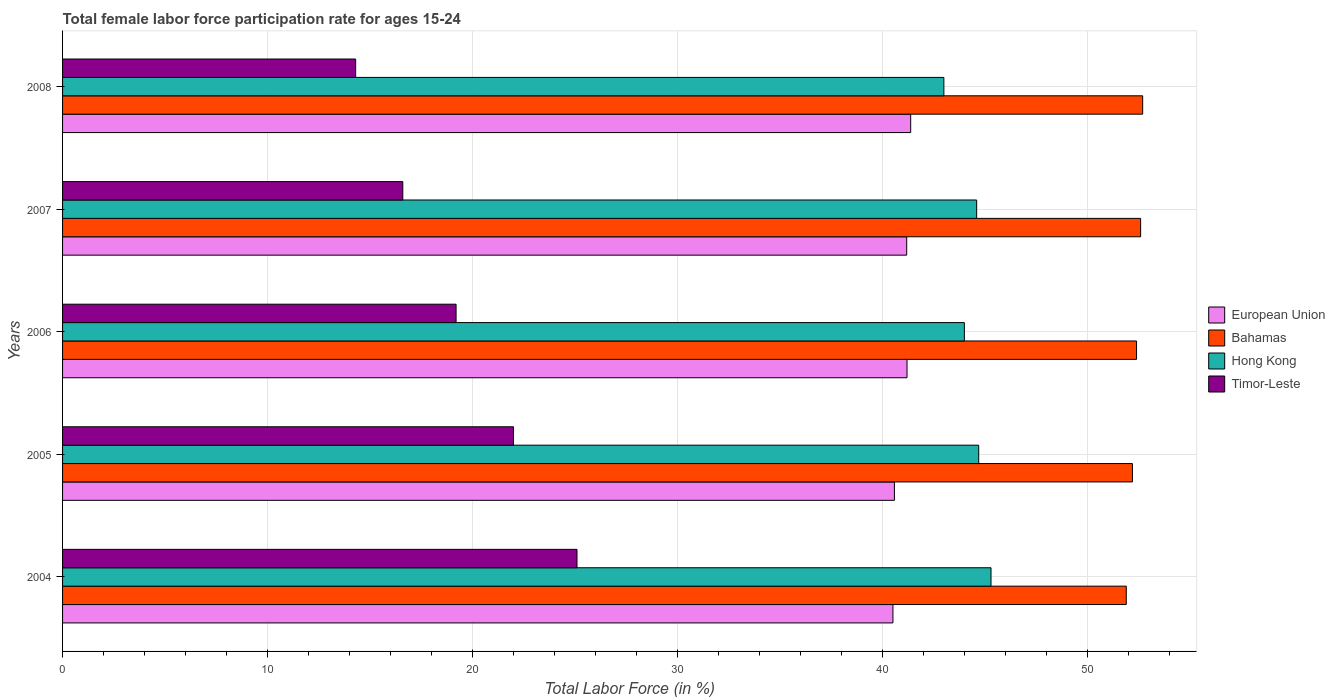How many groups of bars are there?
Give a very brief answer. 5. Are the number of bars per tick equal to the number of legend labels?
Offer a terse response. Yes. Are the number of bars on each tick of the Y-axis equal?
Ensure brevity in your answer.  Yes. How many bars are there on the 3rd tick from the bottom?
Give a very brief answer. 4. In how many cases, is the number of bars for a given year not equal to the number of legend labels?
Your response must be concise. 0. Across all years, what is the maximum female labor force participation rate in European Union?
Offer a terse response. 41.38. Across all years, what is the minimum female labor force participation rate in Hong Kong?
Keep it short and to the point. 43. What is the total female labor force participation rate in Timor-Leste in the graph?
Make the answer very short. 97.2. What is the difference between the female labor force participation rate in European Union in 2005 and the female labor force participation rate in Timor-Leste in 2007?
Offer a terse response. 23.99. What is the average female labor force participation rate in Timor-Leste per year?
Your answer should be compact. 19.44. In the year 2006, what is the difference between the female labor force participation rate in Hong Kong and female labor force participation rate in Bahamas?
Offer a terse response. -8.4. What is the ratio of the female labor force participation rate in Hong Kong in 2006 to that in 2008?
Provide a succinct answer. 1.02. Is the difference between the female labor force participation rate in Hong Kong in 2005 and 2006 greater than the difference between the female labor force participation rate in Bahamas in 2005 and 2006?
Offer a very short reply. Yes. What is the difference between the highest and the second highest female labor force participation rate in Hong Kong?
Offer a terse response. 0.6. What is the difference between the highest and the lowest female labor force participation rate in European Union?
Your answer should be very brief. 0.87. In how many years, is the female labor force participation rate in Hong Kong greater than the average female labor force participation rate in Hong Kong taken over all years?
Your response must be concise. 3. Is it the case that in every year, the sum of the female labor force participation rate in Hong Kong and female labor force participation rate in Timor-Leste is greater than the sum of female labor force participation rate in European Union and female labor force participation rate in Bahamas?
Your answer should be very brief. No. What does the 4th bar from the top in 2004 represents?
Ensure brevity in your answer.  European Union. What does the 3rd bar from the bottom in 2004 represents?
Your answer should be compact. Hong Kong. How many bars are there?
Make the answer very short. 20. How many years are there in the graph?
Your response must be concise. 5. Are the values on the major ticks of X-axis written in scientific E-notation?
Offer a very short reply. No. Does the graph contain any zero values?
Keep it short and to the point. No. How many legend labels are there?
Provide a short and direct response. 4. What is the title of the graph?
Keep it short and to the point. Total female labor force participation rate for ages 15-24. Does "Bermuda" appear as one of the legend labels in the graph?
Provide a short and direct response. No. What is the label or title of the Y-axis?
Provide a short and direct response. Years. What is the Total Labor Force (in %) in European Union in 2004?
Your answer should be compact. 40.51. What is the Total Labor Force (in %) of Bahamas in 2004?
Your answer should be very brief. 51.9. What is the Total Labor Force (in %) in Hong Kong in 2004?
Your answer should be compact. 45.3. What is the Total Labor Force (in %) in Timor-Leste in 2004?
Make the answer very short. 25.1. What is the Total Labor Force (in %) of European Union in 2005?
Offer a very short reply. 40.59. What is the Total Labor Force (in %) of Bahamas in 2005?
Your answer should be very brief. 52.2. What is the Total Labor Force (in %) in Hong Kong in 2005?
Your response must be concise. 44.7. What is the Total Labor Force (in %) in European Union in 2006?
Ensure brevity in your answer.  41.2. What is the Total Labor Force (in %) of Bahamas in 2006?
Offer a very short reply. 52.4. What is the Total Labor Force (in %) in Hong Kong in 2006?
Your answer should be very brief. 44. What is the Total Labor Force (in %) in Timor-Leste in 2006?
Offer a terse response. 19.2. What is the Total Labor Force (in %) in European Union in 2007?
Your response must be concise. 41.19. What is the Total Labor Force (in %) of Bahamas in 2007?
Make the answer very short. 52.6. What is the Total Labor Force (in %) in Hong Kong in 2007?
Provide a short and direct response. 44.6. What is the Total Labor Force (in %) of Timor-Leste in 2007?
Give a very brief answer. 16.6. What is the Total Labor Force (in %) in European Union in 2008?
Give a very brief answer. 41.38. What is the Total Labor Force (in %) of Bahamas in 2008?
Offer a terse response. 52.7. What is the Total Labor Force (in %) in Timor-Leste in 2008?
Give a very brief answer. 14.3. Across all years, what is the maximum Total Labor Force (in %) of European Union?
Provide a succinct answer. 41.38. Across all years, what is the maximum Total Labor Force (in %) in Bahamas?
Make the answer very short. 52.7. Across all years, what is the maximum Total Labor Force (in %) in Hong Kong?
Provide a short and direct response. 45.3. Across all years, what is the maximum Total Labor Force (in %) of Timor-Leste?
Your answer should be very brief. 25.1. Across all years, what is the minimum Total Labor Force (in %) in European Union?
Give a very brief answer. 40.51. Across all years, what is the minimum Total Labor Force (in %) in Bahamas?
Ensure brevity in your answer.  51.9. Across all years, what is the minimum Total Labor Force (in %) of Hong Kong?
Keep it short and to the point. 43. Across all years, what is the minimum Total Labor Force (in %) in Timor-Leste?
Your response must be concise. 14.3. What is the total Total Labor Force (in %) in European Union in the graph?
Keep it short and to the point. 204.87. What is the total Total Labor Force (in %) in Bahamas in the graph?
Provide a succinct answer. 261.8. What is the total Total Labor Force (in %) of Hong Kong in the graph?
Your answer should be compact. 221.6. What is the total Total Labor Force (in %) in Timor-Leste in the graph?
Your response must be concise. 97.2. What is the difference between the Total Labor Force (in %) of European Union in 2004 and that in 2005?
Keep it short and to the point. -0.07. What is the difference between the Total Labor Force (in %) of Bahamas in 2004 and that in 2005?
Provide a succinct answer. -0.3. What is the difference between the Total Labor Force (in %) of Timor-Leste in 2004 and that in 2005?
Your answer should be very brief. 3.1. What is the difference between the Total Labor Force (in %) of European Union in 2004 and that in 2006?
Offer a very short reply. -0.69. What is the difference between the Total Labor Force (in %) of Hong Kong in 2004 and that in 2006?
Provide a succinct answer. 1.3. What is the difference between the Total Labor Force (in %) of Timor-Leste in 2004 and that in 2006?
Offer a very short reply. 5.9. What is the difference between the Total Labor Force (in %) in European Union in 2004 and that in 2007?
Provide a succinct answer. -0.67. What is the difference between the Total Labor Force (in %) in Bahamas in 2004 and that in 2007?
Your answer should be very brief. -0.7. What is the difference between the Total Labor Force (in %) in Hong Kong in 2004 and that in 2007?
Your answer should be compact. 0.7. What is the difference between the Total Labor Force (in %) of European Union in 2004 and that in 2008?
Give a very brief answer. -0.87. What is the difference between the Total Labor Force (in %) in European Union in 2005 and that in 2006?
Your response must be concise. -0.62. What is the difference between the Total Labor Force (in %) of Bahamas in 2005 and that in 2006?
Offer a very short reply. -0.2. What is the difference between the Total Labor Force (in %) in Timor-Leste in 2005 and that in 2006?
Your answer should be very brief. 2.8. What is the difference between the Total Labor Force (in %) in European Union in 2005 and that in 2007?
Make the answer very short. -0.6. What is the difference between the Total Labor Force (in %) in Hong Kong in 2005 and that in 2007?
Your answer should be very brief. 0.1. What is the difference between the Total Labor Force (in %) of European Union in 2005 and that in 2008?
Your response must be concise. -0.79. What is the difference between the Total Labor Force (in %) of Hong Kong in 2005 and that in 2008?
Your answer should be very brief. 1.7. What is the difference between the Total Labor Force (in %) of Timor-Leste in 2005 and that in 2008?
Your answer should be very brief. 7.7. What is the difference between the Total Labor Force (in %) of European Union in 2006 and that in 2007?
Provide a short and direct response. 0.02. What is the difference between the Total Labor Force (in %) of European Union in 2006 and that in 2008?
Give a very brief answer. -0.18. What is the difference between the Total Labor Force (in %) of Bahamas in 2006 and that in 2008?
Keep it short and to the point. -0.3. What is the difference between the Total Labor Force (in %) of Timor-Leste in 2006 and that in 2008?
Offer a terse response. 4.9. What is the difference between the Total Labor Force (in %) in European Union in 2007 and that in 2008?
Provide a succinct answer. -0.19. What is the difference between the Total Labor Force (in %) of Bahamas in 2007 and that in 2008?
Your answer should be very brief. -0.1. What is the difference between the Total Labor Force (in %) in Hong Kong in 2007 and that in 2008?
Your answer should be compact. 1.6. What is the difference between the Total Labor Force (in %) in Timor-Leste in 2007 and that in 2008?
Ensure brevity in your answer.  2.3. What is the difference between the Total Labor Force (in %) of European Union in 2004 and the Total Labor Force (in %) of Bahamas in 2005?
Your answer should be very brief. -11.69. What is the difference between the Total Labor Force (in %) in European Union in 2004 and the Total Labor Force (in %) in Hong Kong in 2005?
Keep it short and to the point. -4.19. What is the difference between the Total Labor Force (in %) in European Union in 2004 and the Total Labor Force (in %) in Timor-Leste in 2005?
Offer a terse response. 18.51. What is the difference between the Total Labor Force (in %) in Bahamas in 2004 and the Total Labor Force (in %) in Timor-Leste in 2005?
Your answer should be very brief. 29.9. What is the difference between the Total Labor Force (in %) of Hong Kong in 2004 and the Total Labor Force (in %) of Timor-Leste in 2005?
Your answer should be very brief. 23.3. What is the difference between the Total Labor Force (in %) of European Union in 2004 and the Total Labor Force (in %) of Bahamas in 2006?
Your answer should be compact. -11.89. What is the difference between the Total Labor Force (in %) in European Union in 2004 and the Total Labor Force (in %) in Hong Kong in 2006?
Ensure brevity in your answer.  -3.49. What is the difference between the Total Labor Force (in %) in European Union in 2004 and the Total Labor Force (in %) in Timor-Leste in 2006?
Your answer should be compact. 21.31. What is the difference between the Total Labor Force (in %) of Bahamas in 2004 and the Total Labor Force (in %) of Hong Kong in 2006?
Provide a short and direct response. 7.9. What is the difference between the Total Labor Force (in %) in Bahamas in 2004 and the Total Labor Force (in %) in Timor-Leste in 2006?
Offer a very short reply. 32.7. What is the difference between the Total Labor Force (in %) of Hong Kong in 2004 and the Total Labor Force (in %) of Timor-Leste in 2006?
Give a very brief answer. 26.1. What is the difference between the Total Labor Force (in %) of European Union in 2004 and the Total Labor Force (in %) of Bahamas in 2007?
Give a very brief answer. -12.09. What is the difference between the Total Labor Force (in %) of European Union in 2004 and the Total Labor Force (in %) of Hong Kong in 2007?
Offer a very short reply. -4.09. What is the difference between the Total Labor Force (in %) of European Union in 2004 and the Total Labor Force (in %) of Timor-Leste in 2007?
Keep it short and to the point. 23.91. What is the difference between the Total Labor Force (in %) in Bahamas in 2004 and the Total Labor Force (in %) in Hong Kong in 2007?
Ensure brevity in your answer.  7.3. What is the difference between the Total Labor Force (in %) in Bahamas in 2004 and the Total Labor Force (in %) in Timor-Leste in 2007?
Make the answer very short. 35.3. What is the difference between the Total Labor Force (in %) of Hong Kong in 2004 and the Total Labor Force (in %) of Timor-Leste in 2007?
Offer a terse response. 28.7. What is the difference between the Total Labor Force (in %) in European Union in 2004 and the Total Labor Force (in %) in Bahamas in 2008?
Your answer should be very brief. -12.19. What is the difference between the Total Labor Force (in %) in European Union in 2004 and the Total Labor Force (in %) in Hong Kong in 2008?
Make the answer very short. -2.49. What is the difference between the Total Labor Force (in %) of European Union in 2004 and the Total Labor Force (in %) of Timor-Leste in 2008?
Offer a terse response. 26.21. What is the difference between the Total Labor Force (in %) of Bahamas in 2004 and the Total Labor Force (in %) of Hong Kong in 2008?
Offer a very short reply. 8.9. What is the difference between the Total Labor Force (in %) in Bahamas in 2004 and the Total Labor Force (in %) in Timor-Leste in 2008?
Keep it short and to the point. 37.6. What is the difference between the Total Labor Force (in %) in Hong Kong in 2004 and the Total Labor Force (in %) in Timor-Leste in 2008?
Keep it short and to the point. 31. What is the difference between the Total Labor Force (in %) of European Union in 2005 and the Total Labor Force (in %) of Bahamas in 2006?
Provide a succinct answer. -11.81. What is the difference between the Total Labor Force (in %) of European Union in 2005 and the Total Labor Force (in %) of Hong Kong in 2006?
Give a very brief answer. -3.41. What is the difference between the Total Labor Force (in %) of European Union in 2005 and the Total Labor Force (in %) of Timor-Leste in 2006?
Offer a terse response. 21.39. What is the difference between the Total Labor Force (in %) in Bahamas in 2005 and the Total Labor Force (in %) in Timor-Leste in 2006?
Your response must be concise. 33. What is the difference between the Total Labor Force (in %) in European Union in 2005 and the Total Labor Force (in %) in Bahamas in 2007?
Give a very brief answer. -12.01. What is the difference between the Total Labor Force (in %) of European Union in 2005 and the Total Labor Force (in %) of Hong Kong in 2007?
Your response must be concise. -4.01. What is the difference between the Total Labor Force (in %) of European Union in 2005 and the Total Labor Force (in %) of Timor-Leste in 2007?
Provide a succinct answer. 23.99. What is the difference between the Total Labor Force (in %) of Bahamas in 2005 and the Total Labor Force (in %) of Hong Kong in 2007?
Offer a terse response. 7.6. What is the difference between the Total Labor Force (in %) in Bahamas in 2005 and the Total Labor Force (in %) in Timor-Leste in 2007?
Provide a succinct answer. 35.6. What is the difference between the Total Labor Force (in %) of Hong Kong in 2005 and the Total Labor Force (in %) of Timor-Leste in 2007?
Your answer should be compact. 28.1. What is the difference between the Total Labor Force (in %) in European Union in 2005 and the Total Labor Force (in %) in Bahamas in 2008?
Give a very brief answer. -12.11. What is the difference between the Total Labor Force (in %) in European Union in 2005 and the Total Labor Force (in %) in Hong Kong in 2008?
Provide a short and direct response. -2.41. What is the difference between the Total Labor Force (in %) in European Union in 2005 and the Total Labor Force (in %) in Timor-Leste in 2008?
Ensure brevity in your answer.  26.29. What is the difference between the Total Labor Force (in %) of Bahamas in 2005 and the Total Labor Force (in %) of Hong Kong in 2008?
Keep it short and to the point. 9.2. What is the difference between the Total Labor Force (in %) of Bahamas in 2005 and the Total Labor Force (in %) of Timor-Leste in 2008?
Your answer should be compact. 37.9. What is the difference between the Total Labor Force (in %) in Hong Kong in 2005 and the Total Labor Force (in %) in Timor-Leste in 2008?
Your response must be concise. 30.4. What is the difference between the Total Labor Force (in %) of European Union in 2006 and the Total Labor Force (in %) of Bahamas in 2007?
Offer a very short reply. -11.4. What is the difference between the Total Labor Force (in %) of European Union in 2006 and the Total Labor Force (in %) of Hong Kong in 2007?
Provide a succinct answer. -3.4. What is the difference between the Total Labor Force (in %) of European Union in 2006 and the Total Labor Force (in %) of Timor-Leste in 2007?
Offer a very short reply. 24.6. What is the difference between the Total Labor Force (in %) in Bahamas in 2006 and the Total Labor Force (in %) in Hong Kong in 2007?
Offer a terse response. 7.8. What is the difference between the Total Labor Force (in %) of Bahamas in 2006 and the Total Labor Force (in %) of Timor-Leste in 2007?
Your response must be concise. 35.8. What is the difference between the Total Labor Force (in %) of Hong Kong in 2006 and the Total Labor Force (in %) of Timor-Leste in 2007?
Provide a short and direct response. 27.4. What is the difference between the Total Labor Force (in %) of European Union in 2006 and the Total Labor Force (in %) of Bahamas in 2008?
Provide a short and direct response. -11.5. What is the difference between the Total Labor Force (in %) of European Union in 2006 and the Total Labor Force (in %) of Hong Kong in 2008?
Make the answer very short. -1.8. What is the difference between the Total Labor Force (in %) of European Union in 2006 and the Total Labor Force (in %) of Timor-Leste in 2008?
Your answer should be compact. 26.9. What is the difference between the Total Labor Force (in %) in Bahamas in 2006 and the Total Labor Force (in %) in Hong Kong in 2008?
Offer a very short reply. 9.4. What is the difference between the Total Labor Force (in %) of Bahamas in 2006 and the Total Labor Force (in %) of Timor-Leste in 2008?
Make the answer very short. 38.1. What is the difference between the Total Labor Force (in %) of Hong Kong in 2006 and the Total Labor Force (in %) of Timor-Leste in 2008?
Provide a succinct answer. 29.7. What is the difference between the Total Labor Force (in %) in European Union in 2007 and the Total Labor Force (in %) in Bahamas in 2008?
Make the answer very short. -11.51. What is the difference between the Total Labor Force (in %) of European Union in 2007 and the Total Labor Force (in %) of Hong Kong in 2008?
Offer a very short reply. -1.81. What is the difference between the Total Labor Force (in %) of European Union in 2007 and the Total Labor Force (in %) of Timor-Leste in 2008?
Keep it short and to the point. 26.89. What is the difference between the Total Labor Force (in %) of Bahamas in 2007 and the Total Labor Force (in %) of Hong Kong in 2008?
Make the answer very short. 9.6. What is the difference between the Total Labor Force (in %) of Bahamas in 2007 and the Total Labor Force (in %) of Timor-Leste in 2008?
Offer a terse response. 38.3. What is the difference between the Total Labor Force (in %) of Hong Kong in 2007 and the Total Labor Force (in %) of Timor-Leste in 2008?
Ensure brevity in your answer.  30.3. What is the average Total Labor Force (in %) of European Union per year?
Keep it short and to the point. 40.97. What is the average Total Labor Force (in %) of Bahamas per year?
Offer a terse response. 52.36. What is the average Total Labor Force (in %) in Hong Kong per year?
Your response must be concise. 44.32. What is the average Total Labor Force (in %) in Timor-Leste per year?
Give a very brief answer. 19.44. In the year 2004, what is the difference between the Total Labor Force (in %) of European Union and Total Labor Force (in %) of Bahamas?
Make the answer very short. -11.39. In the year 2004, what is the difference between the Total Labor Force (in %) in European Union and Total Labor Force (in %) in Hong Kong?
Provide a short and direct response. -4.79. In the year 2004, what is the difference between the Total Labor Force (in %) in European Union and Total Labor Force (in %) in Timor-Leste?
Keep it short and to the point. 15.41. In the year 2004, what is the difference between the Total Labor Force (in %) of Bahamas and Total Labor Force (in %) of Hong Kong?
Keep it short and to the point. 6.6. In the year 2004, what is the difference between the Total Labor Force (in %) in Bahamas and Total Labor Force (in %) in Timor-Leste?
Keep it short and to the point. 26.8. In the year 2004, what is the difference between the Total Labor Force (in %) in Hong Kong and Total Labor Force (in %) in Timor-Leste?
Your response must be concise. 20.2. In the year 2005, what is the difference between the Total Labor Force (in %) in European Union and Total Labor Force (in %) in Bahamas?
Ensure brevity in your answer.  -11.61. In the year 2005, what is the difference between the Total Labor Force (in %) of European Union and Total Labor Force (in %) of Hong Kong?
Ensure brevity in your answer.  -4.11. In the year 2005, what is the difference between the Total Labor Force (in %) in European Union and Total Labor Force (in %) in Timor-Leste?
Provide a short and direct response. 18.59. In the year 2005, what is the difference between the Total Labor Force (in %) in Bahamas and Total Labor Force (in %) in Hong Kong?
Your response must be concise. 7.5. In the year 2005, what is the difference between the Total Labor Force (in %) of Bahamas and Total Labor Force (in %) of Timor-Leste?
Give a very brief answer. 30.2. In the year 2005, what is the difference between the Total Labor Force (in %) of Hong Kong and Total Labor Force (in %) of Timor-Leste?
Keep it short and to the point. 22.7. In the year 2006, what is the difference between the Total Labor Force (in %) of European Union and Total Labor Force (in %) of Bahamas?
Offer a terse response. -11.2. In the year 2006, what is the difference between the Total Labor Force (in %) of European Union and Total Labor Force (in %) of Hong Kong?
Provide a succinct answer. -2.8. In the year 2006, what is the difference between the Total Labor Force (in %) in European Union and Total Labor Force (in %) in Timor-Leste?
Give a very brief answer. 22. In the year 2006, what is the difference between the Total Labor Force (in %) of Bahamas and Total Labor Force (in %) of Timor-Leste?
Provide a short and direct response. 33.2. In the year 2006, what is the difference between the Total Labor Force (in %) of Hong Kong and Total Labor Force (in %) of Timor-Leste?
Ensure brevity in your answer.  24.8. In the year 2007, what is the difference between the Total Labor Force (in %) in European Union and Total Labor Force (in %) in Bahamas?
Your answer should be very brief. -11.41. In the year 2007, what is the difference between the Total Labor Force (in %) of European Union and Total Labor Force (in %) of Hong Kong?
Your response must be concise. -3.41. In the year 2007, what is the difference between the Total Labor Force (in %) in European Union and Total Labor Force (in %) in Timor-Leste?
Your answer should be very brief. 24.59. In the year 2007, what is the difference between the Total Labor Force (in %) in Bahamas and Total Labor Force (in %) in Hong Kong?
Make the answer very short. 8. In the year 2008, what is the difference between the Total Labor Force (in %) of European Union and Total Labor Force (in %) of Bahamas?
Keep it short and to the point. -11.32. In the year 2008, what is the difference between the Total Labor Force (in %) of European Union and Total Labor Force (in %) of Hong Kong?
Offer a very short reply. -1.62. In the year 2008, what is the difference between the Total Labor Force (in %) of European Union and Total Labor Force (in %) of Timor-Leste?
Keep it short and to the point. 27.08. In the year 2008, what is the difference between the Total Labor Force (in %) of Bahamas and Total Labor Force (in %) of Hong Kong?
Your answer should be very brief. 9.7. In the year 2008, what is the difference between the Total Labor Force (in %) in Bahamas and Total Labor Force (in %) in Timor-Leste?
Offer a terse response. 38.4. In the year 2008, what is the difference between the Total Labor Force (in %) in Hong Kong and Total Labor Force (in %) in Timor-Leste?
Your response must be concise. 28.7. What is the ratio of the Total Labor Force (in %) in Hong Kong in 2004 to that in 2005?
Keep it short and to the point. 1.01. What is the ratio of the Total Labor Force (in %) in Timor-Leste in 2004 to that in 2005?
Keep it short and to the point. 1.14. What is the ratio of the Total Labor Force (in %) in European Union in 2004 to that in 2006?
Keep it short and to the point. 0.98. What is the ratio of the Total Labor Force (in %) of Hong Kong in 2004 to that in 2006?
Offer a very short reply. 1.03. What is the ratio of the Total Labor Force (in %) of Timor-Leste in 2004 to that in 2006?
Keep it short and to the point. 1.31. What is the ratio of the Total Labor Force (in %) in European Union in 2004 to that in 2007?
Offer a very short reply. 0.98. What is the ratio of the Total Labor Force (in %) of Bahamas in 2004 to that in 2007?
Your answer should be very brief. 0.99. What is the ratio of the Total Labor Force (in %) in Hong Kong in 2004 to that in 2007?
Ensure brevity in your answer.  1.02. What is the ratio of the Total Labor Force (in %) in Timor-Leste in 2004 to that in 2007?
Your response must be concise. 1.51. What is the ratio of the Total Labor Force (in %) in European Union in 2004 to that in 2008?
Your response must be concise. 0.98. What is the ratio of the Total Labor Force (in %) of Bahamas in 2004 to that in 2008?
Ensure brevity in your answer.  0.98. What is the ratio of the Total Labor Force (in %) in Hong Kong in 2004 to that in 2008?
Offer a terse response. 1.05. What is the ratio of the Total Labor Force (in %) of Timor-Leste in 2004 to that in 2008?
Offer a terse response. 1.76. What is the ratio of the Total Labor Force (in %) in European Union in 2005 to that in 2006?
Make the answer very short. 0.99. What is the ratio of the Total Labor Force (in %) of Hong Kong in 2005 to that in 2006?
Your response must be concise. 1.02. What is the ratio of the Total Labor Force (in %) of Timor-Leste in 2005 to that in 2006?
Your answer should be very brief. 1.15. What is the ratio of the Total Labor Force (in %) in European Union in 2005 to that in 2007?
Keep it short and to the point. 0.99. What is the ratio of the Total Labor Force (in %) of Hong Kong in 2005 to that in 2007?
Your answer should be very brief. 1. What is the ratio of the Total Labor Force (in %) of Timor-Leste in 2005 to that in 2007?
Your answer should be compact. 1.33. What is the ratio of the Total Labor Force (in %) in European Union in 2005 to that in 2008?
Make the answer very short. 0.98. What is the ratio of the Total Labor Force (in %) in Bahamas in 2005 to that in 2008?
Keep it short and to the point. 0.99. What is the ratio of the Total Labor Force (in %) in Hong Kong in 2005 to that in 2008?
Make the answer very short. 1.04. What is the ratio of the Total Labor Force (in %) in Timor-Leste in 2005 to that in 2008?
Your answer should be very brief. 1.54. What is the ratio of the Total Labor Force (in %) in European Union in 2006 to that in 2007?
Your answer should be very brief. 1. What is the ratio of the Total Labor Force (in %) of Hong Kong in 2006 to that in 2007?
Offer a terse response. 0.99. What is the ratio of the Total Labor Force (in %) in Timor-Leste in 2006 to that in 2007?
Your response must be concise. 1.16. What is the ratio of the Total Labor Force (in %) of Bahamas in 2006 to that in 2008?
Provide a short and direct response. 0.99. What is the ratio of the Total Labor Force (in %) in Hong Kong in 2006 to that in 2008?
Provide a succinct answer. 1.02. What is the ratio of the Total Labor Force (in %) in Timor-Leste in 2006 to that in 2008?
Offer a very short reply. 1.34. What is the ratio of the Total Labor Force (in %) of Bahamas in 2007 to that in 2008?
Your answer should be compact. 1. What is the ratio of the Total Labor Force (in %) of Hong Kong in 2007 to that in 2008?
Provide a short and direct response. 1.04. What is the ratio of the Total Labor Force (in %) in Timor-Leste in 2007 to that in 2008?
Offer a terse response. 1.16. What is the difference between the highest and the second highest Total Labor Force (in %) in European Union?
Provide a short and direct response. 0.18. What is the difference between the highest and the second highest Total Labor Force (in %) of Bahamas?
Provide a short and direct response. 0.1. What is the difference between the highest and the lowest Total Labor Force (in %) of European Union?
Make the answer very short. 0.87. What is the difference between the highest and the lowest Total Labor Force (in %) of Timor-Leste?
Provide a succinct answer. 10.8. 